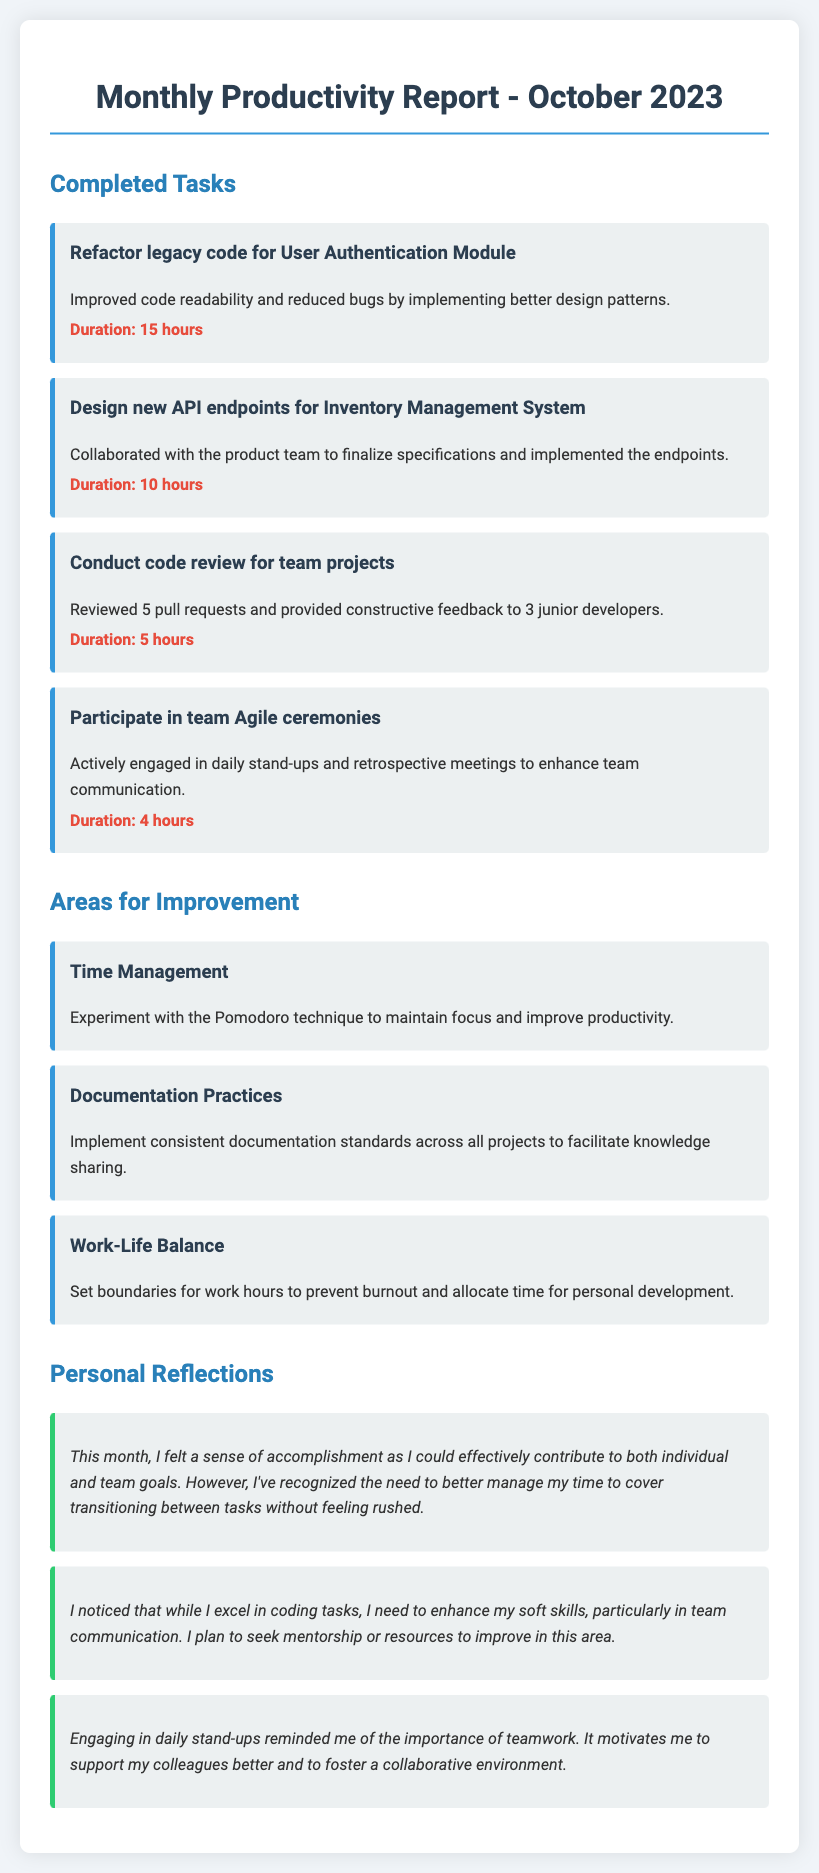What is the title of the document? The title is mentioned in the header of the document, indicating it is the Monthly Productivity Report for October 2023.
Answer: Monthly Productivity Report - October 2023 How many completed tasks are listed? The document specifies four completed tasks under the "Completed Tasks" section.
Answer: 4 What task took the longest to complete? The task with the longest duration is indicated by the duration mentioned, which is for Refactoring the legacy code for User Authentication Module.
Answer: Refactor legacy code for User Authentication Module What is one area for improvement mentioned? The document outlines three areas for improvement, including Time Management.
Answer: Time Management What is a personal reflection shared in the document? The document contains multiple reflections; one key reflection is about the importance of teamwork as emphasized by the daily stand-ups.
Answer: Importance of teamwork What is the duration of the task related to conducting code reviews? The document specifies the duration for Conducting code review for team projects, which is 5 hours.
Answer: 5 hours What technique does the document suggest for time management? It mentions experimenting with the Pomodoro technique as a suggested method for better time management.
Answer: Pomodoro technique How many pull requests were reviewed? The document states that 5 pull requests were reviewed during the code review task.
Answer: 5 pull requests 